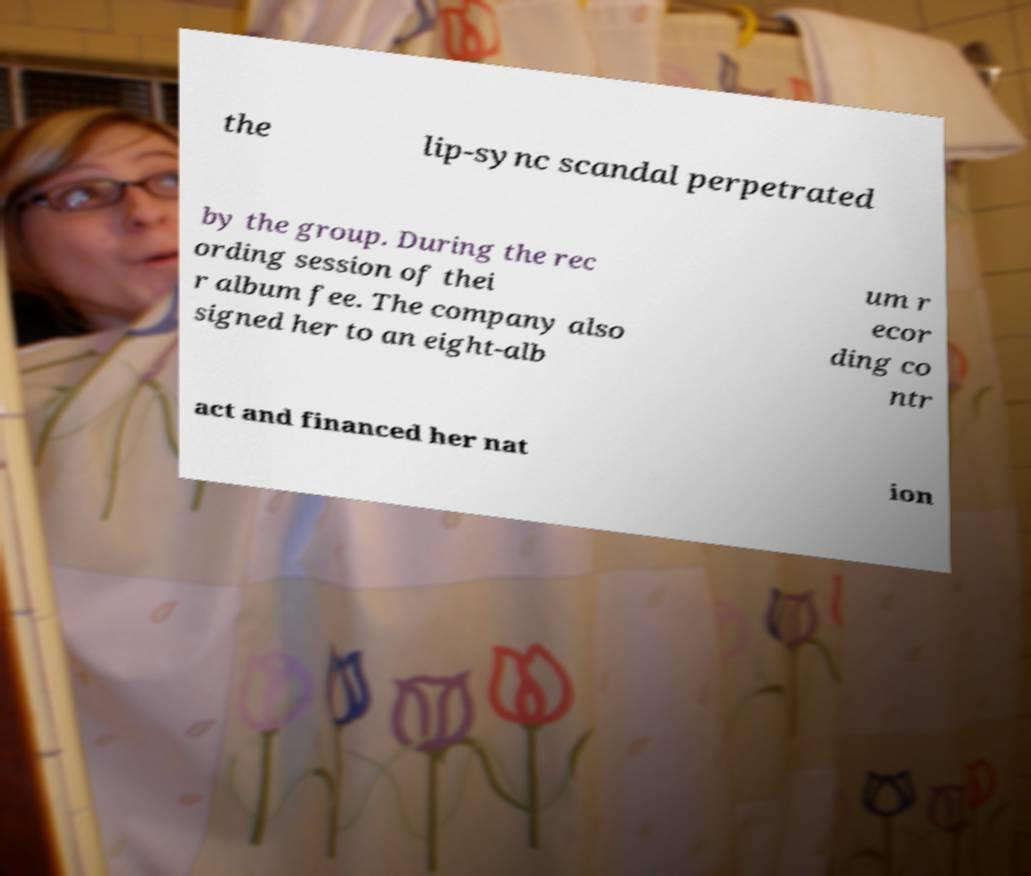Can you accurately transcribe the text from the provided image for me? the lip-sync scandal perpetrated by the group. During the rec ording session of thei r album fee. The company also signed her to an eight-alb um r ecor ding co ntr act and financed her nat ion 